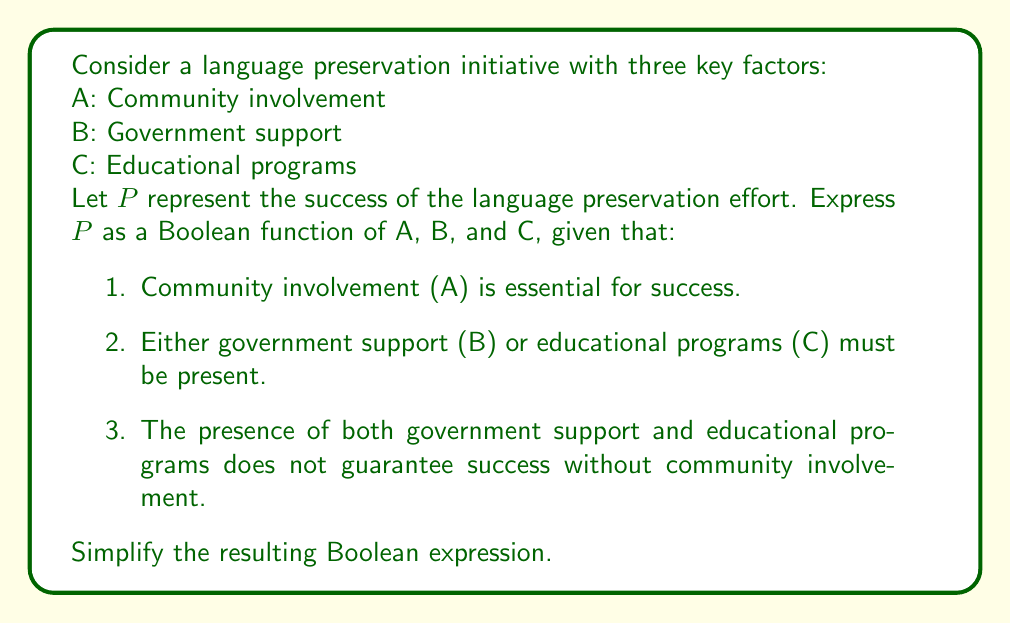Show me your answer to this math problem. Let's approach this step-by-step:

1. Community involvement (A) is essential for success, so A must be present in all terms of our function:
   $P = A \cdot (\text{other factors})$

2. Either government support (B) or educational programs (C) must be present. This can be expressed as (B + C):
   $P = A \cdot (B + C)$

3. The presence of both B and C without A does not guarantee success, which is already accounted for in our current expression.

Therefore, our Boolean function is:
   $P = A \cdot (B + C)$

To simplify, we can expand this using the distributive property:
   $P = A \cdot B + A \cdot C$

This expression is already in its simplest form (sum of products), so no further simplification is needed.

In Boolean algebra terms, this means that the language preservation effort will be successful if:
- Community involvement (A) AND government support (B) are present, OR
- Community involvement (A) AND educational programs (C) are present.
Answer: $P = A \cdot (B + C)$ or $P = A \cdot B + A \cdot C$ 